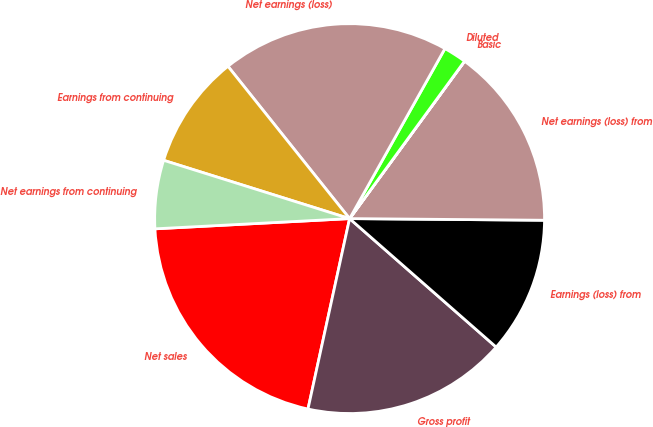<chart> <loc_0><loc_0><loc_500><loc_500><pie_chart><fcel>Net sales<fcel>Gross profit<fcel>Earnings (loss) from<fcel>Net earnings (loss) from<fcel>Basic<fcel>Diluted<fcel>Net earnings (loss)<fcel>Earnings from continuing<fcel>Net earnings from continuing<nl><fcel>20.74%<fcel>16.97%<fcel>11.32%<fcel>15.09%<fcel>0.01%<fcel>1.9%<fcel>18.86%<fcel>9.44%<fcel>5.67%<nl></chart> 